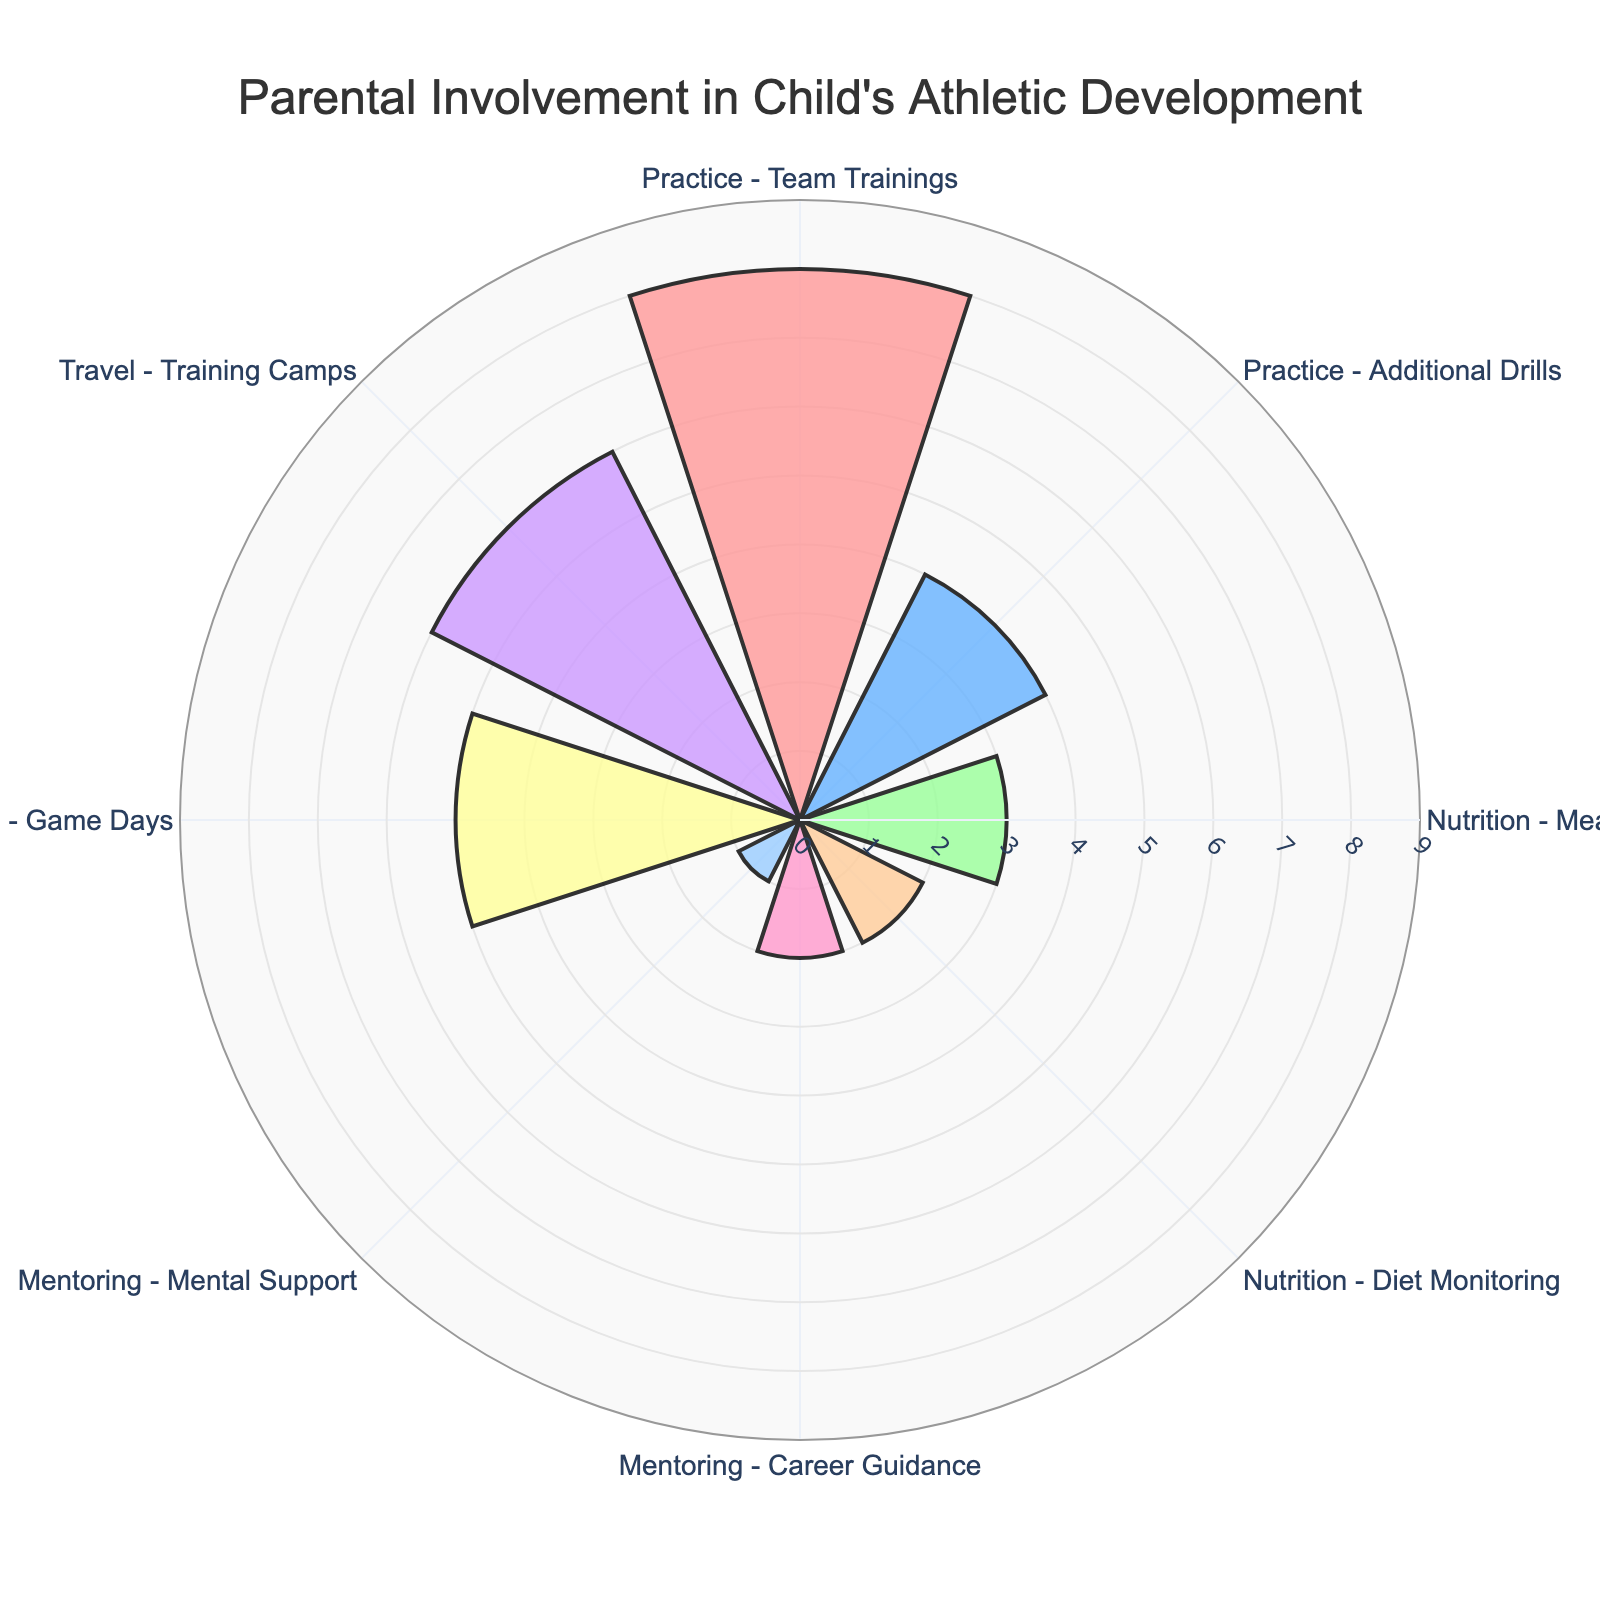What is the title of the figure? The title is usually displayed at the top of the figure. Here, it indicates the main focus of the figure, which is about parental involvement in a child's athletic development.
Answer: Parental Involvement in Child's Athletic Development How many different activities are shown in the figure? By counting the number of segments or labels in the rose chart, we can determine the number of distinct activities involved.
Answer: 8 Which activity has the highest weekly hours dedicated to it? We need to find the activity with the largest radial length. "Practice - Team Trainings" has the longest segment.
Answer: Practice - Team Trainings How many hours per week are spent on Nutrition - Meal Planning? Look for the segment labeled "Nutrition - Meal Planning" and note the radial length. It’s 3 hours per week.
Answer: 3 What is the total number of hours spent per week on all Mentoring activities combined? Sum the hours spent on "Mentoring - Career Guidance" and "Mentoring - Mental Support". That's 2 + 1 hours.
Answer: 3 Which activity involves the most travel time? Among the activities related to travel, "Travel - Training Camps" has the highest radial length.
Answer: Travel - Training Camps What is the total number of weeks spent on Practice - Additional Drills and Travel - Game Days? Sum the weeks spent on these activities: 30 weeks for Practice - Additional Drills and 20 weeks for Travel - Game Days, respectively.
Answer: 50 weeks Compare the time spent on Practice - Team Trainings to Nutrition - Diet Monitoring. Which is higher and by how much? Subtract the hours per week for Nutrition - Diet Monitoring (2 hours) from Practice - Team Trainings (8 hours). 8 - 2 = 6 hours more for Practice - Team Trainings.
Answer: Practice - Team Trainings, 6 hours more What percentage of weeks in a year is spent on Nutrition - Meal Planning? Since there are 52 weeks in a year, calculate the percentage as (Weeks Spent / 52) * 100. For Nutrition - Meal Planning, (52/52) * 100 = 100%.
Answer: 100% Is the time spent on Travel - Game Days equal to the time spent on Practice - Additional Drills? Compare the hours per week for both activities: Travel - Game Days (5 hours) is more than Practice - Additional Drills (4 hours).
Answer: No 